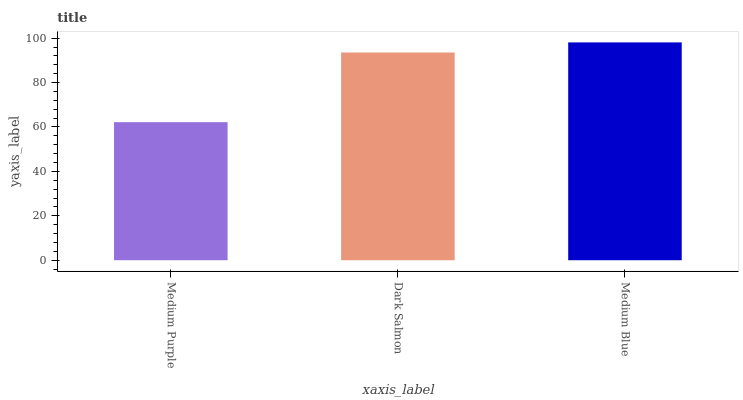Is Medium Purple the minimum?
Answer yes or no. Yes. Is Medium Blue the maximum?
Answer yes or no. Yes. Is Dark Salmon the minimum?
Answer yes or no. No. Is Dark Salmon the maximum?
Answer yes or no. No. Is Dark Salmon greater than Medium Purple?
Answer yes or no. Yes. Is Medium Purple less than Dark Salmon?
Answer yes or no. Yes. Is Medium Purple greater than Dark Salmon?
Answer yes or no. No. Is Dark Salmon less than Medium Purple?
Answer yes or no. No. Is Dark Salmon the high median?
Answer yes or no. Yes. Is Dark Salmon the low median?
Answer yes or no. Yes. Is Medium Blue the high median?
Answer yes or no. No. Is Medium Blue the low median?
Answer yes or no. No. 